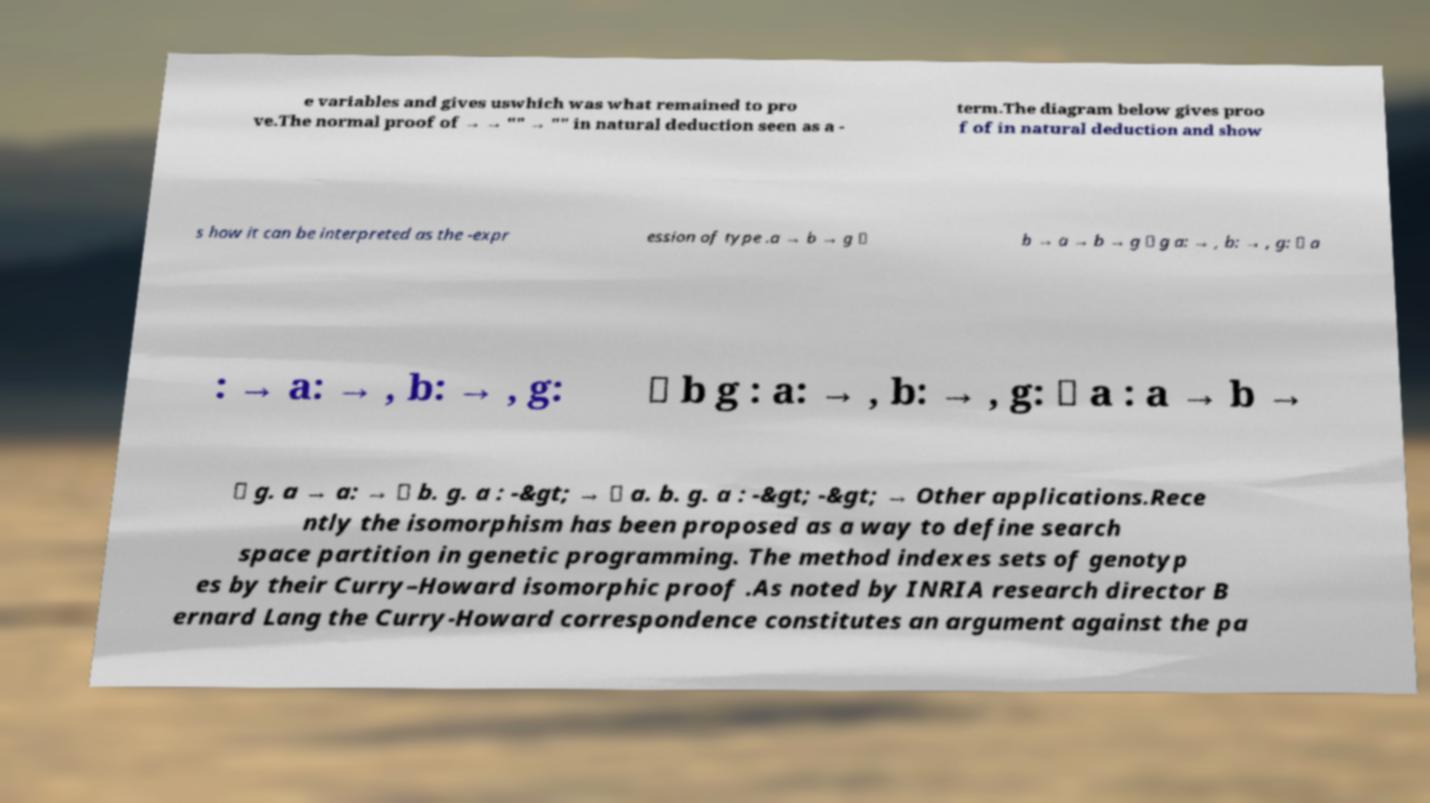Can you read and provide the text displayed in the image?This photo seems to have some interesting text. Can you extract and type it out for me? e variables and gives uswhich was what remained to pro ve.The normal proof of → → "" → "" in natural deduction seen as a - term.The diagram below gives proo f of in natural deduction and show s how it can be interpreted as the -expr ession of type .a → b → g ⊢ b → a → b → g ⊢ g a: → , b: → , g: ⊢ a : → a: → , b: → , g: ⊢ b g : a: → , b: → , g: ⊢ a : a → b → ⊢ g. a → a: → ⊢ b. g. a : -&gt; → ⊢ a. b. g. a : -&gt; -&gt; → Other applications.Rece ntly the isomorphism has been proposed as a way to define search space partition in genetic programming. The method indexes sets of genotyp es by their Curry–Howard isomorphic proof .As noted by INRIA research director B ernard Lang the Curry-Howard correspondence constitutes an argument against the pa 